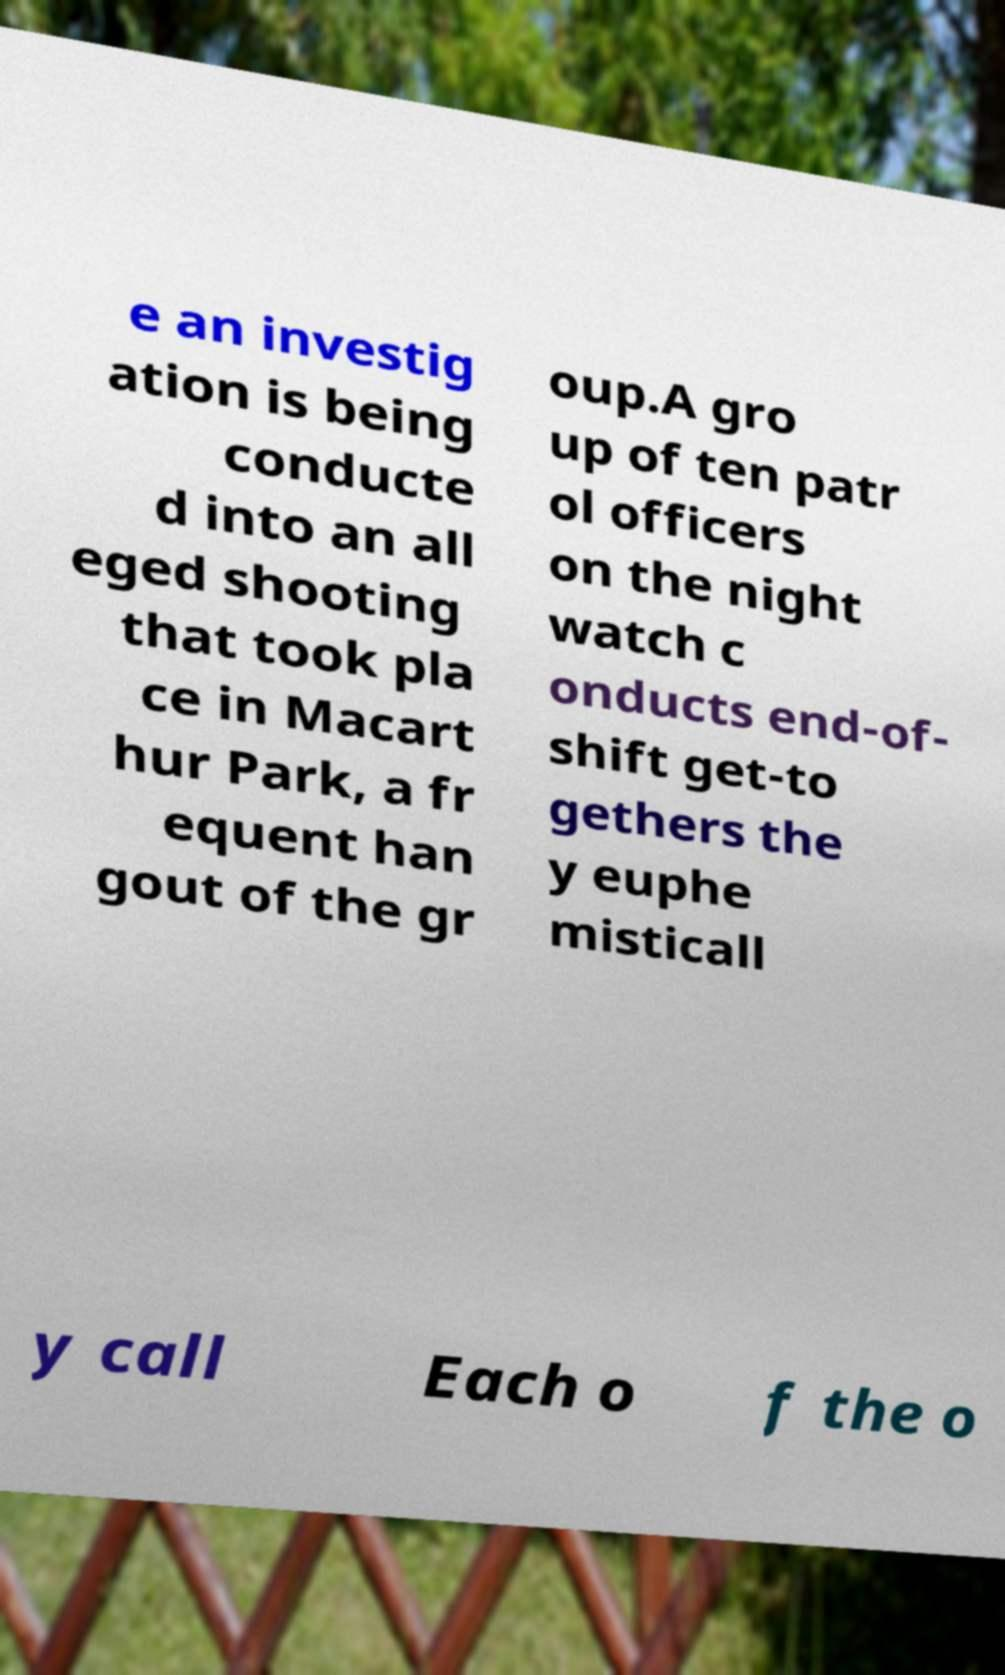Could you assist in decoding the text presented in this image and type it out clearly? e an investig ation is being conducte d into an all eged shooting that took pla ce in Macart hur Park, a fr equent han gout of the gr oup.A gro up of ten patr ol officers on the night watch c onducts end-of- shift get-to gethers the y euphe misticall y call Each o f the o 